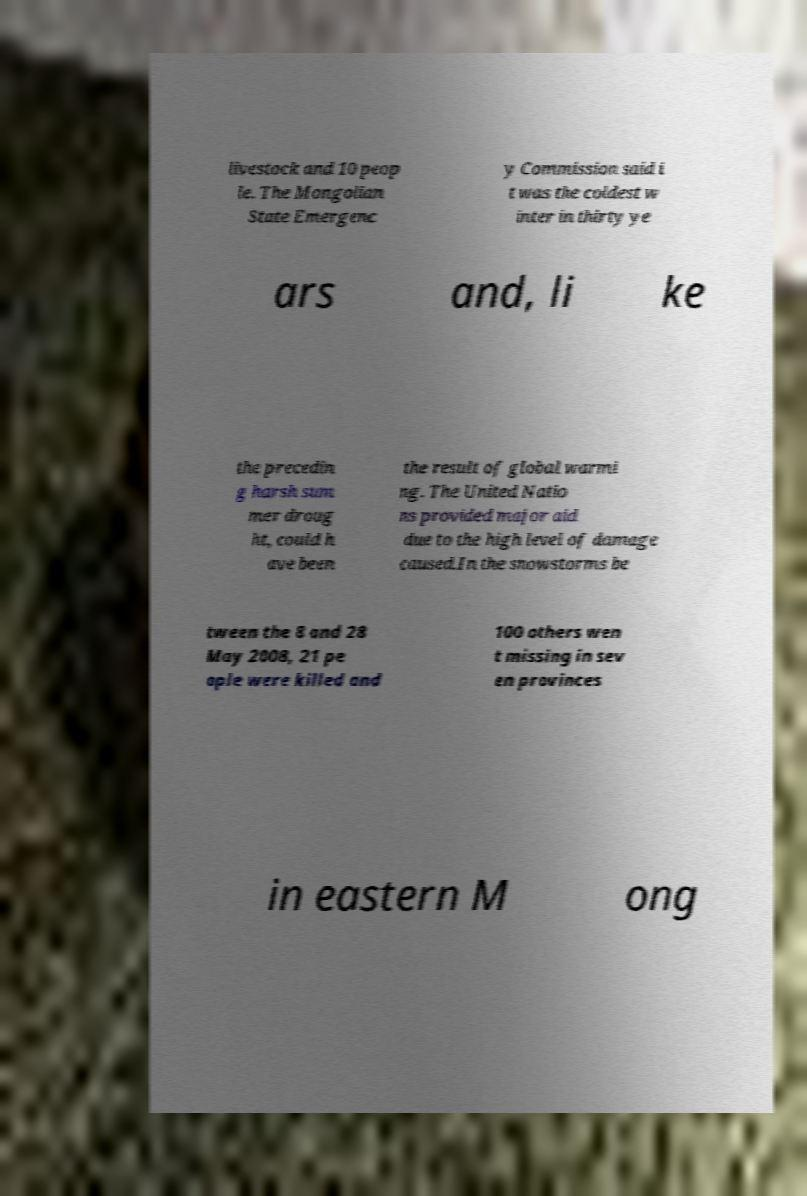Please identify and transcribe the text found in this image. livestock and 10 peop le. The Mongolian State Emergenc y Commission said i t was the coldest w inter in thirty ye ars and, li ke the precedin g harsh sum mer droug ht, could h ave been the result of global warmi ng. The United Natio ns provided major aid due to the high level of damage caused.In the snowstorms be tween the 8 and 28 May 2008, 21 pe ople were killed and 100 others wen t missing in sev en provinces in eastern M ong 